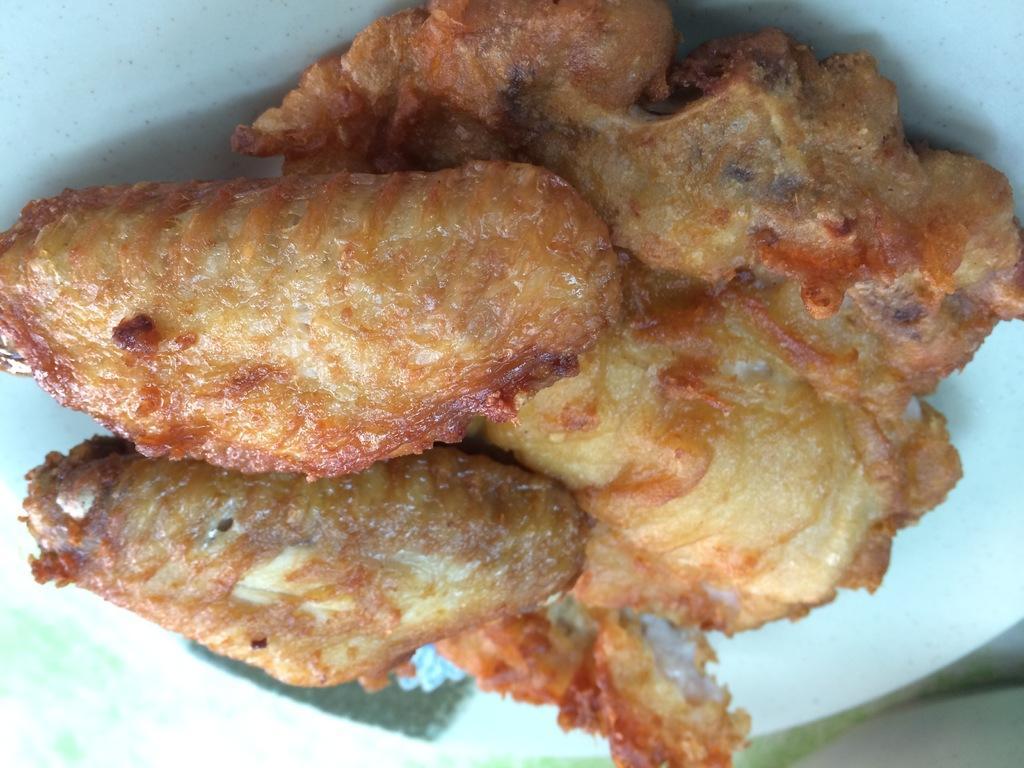Could you give a brief overview of what you see in this image? In the image i can see a white plate which is filled of food item. 